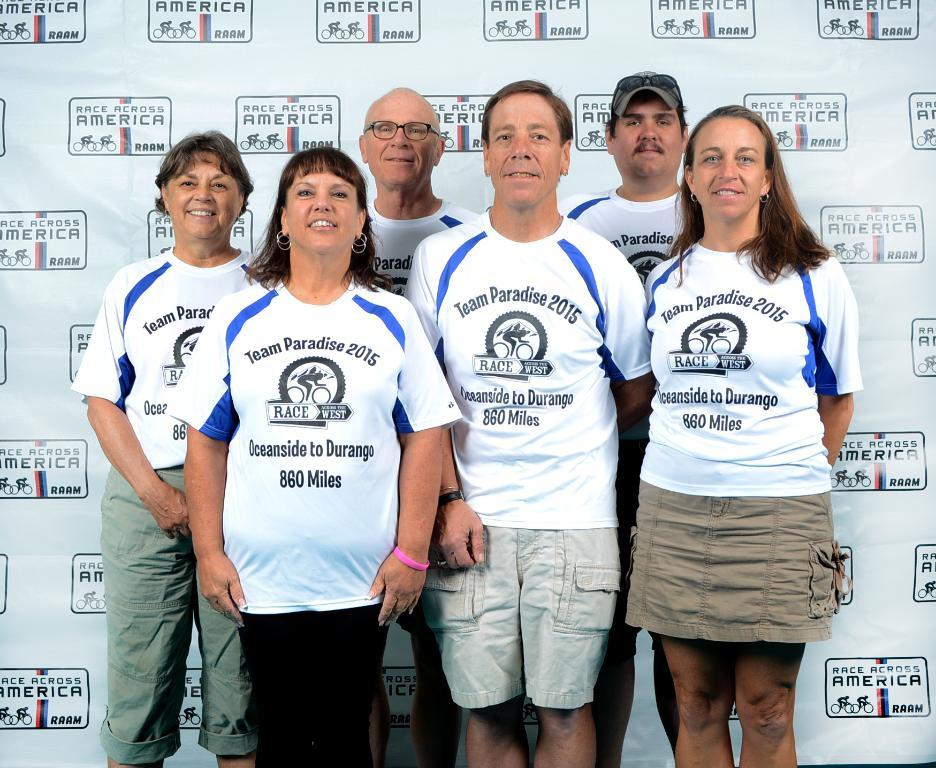Who or what is present in the image? There are people in the image. What is the emotional state of the people in the image? The people are smiling. Is there any text visible in the image? Yes, there is a banner with text in the image. What type of quiver can be seen in the image? There is no quiver present in the image. 